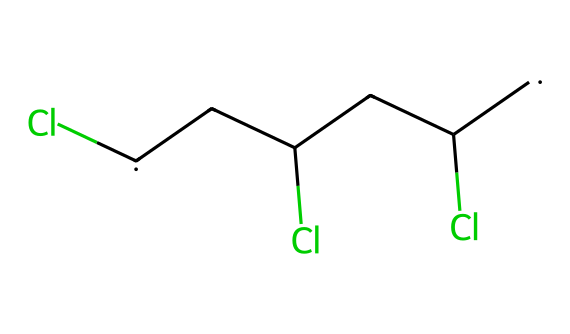What is the primary element in this chemical structure? The chemical structure includes multiple atoms of carbon (C) and chlorine (Cl), but chlorine is the most notable compared to typical hydrocarbons.
Answer: chlorine How many carbon atoms are present in this structure? By analysing the SMILES representation, there are four carbon atoms denoted by [CH2] units.
Answer: four What is the total number of chlorine atoms in this chemical? From the SMILES, there are three chlorine atoms connected to the carbon backbone, indicated by the occurrences of (Cl) within the representation.
Answer: three What type of bond links the carbon atoms here? The carbon atoms are linked with single covalent bonds as represented by the structure in the SMILES, thus indicating saturated connectivity.
Answer: single What property does the presence of chlorine suggest about this chemical? The presence of chlorine indicates that the chemical is more polar and can affect properties like solubility and reactivity, often enhancing flame resistance in plastics.
Answer: polar What is the main use of this chemical in industry? Given its properties, this chemical is primarily used in construction and plumbing, recognized for durability and resistance to corrosion.
Answer: construction and plumbing How does the structure influence the flexibility of the material made from this chemical? The presence of multiple carbon and chlorine atoms promotes rigidity in the polymer chains while limiting flexibility compared to other plastics.
Answer: rigidity 